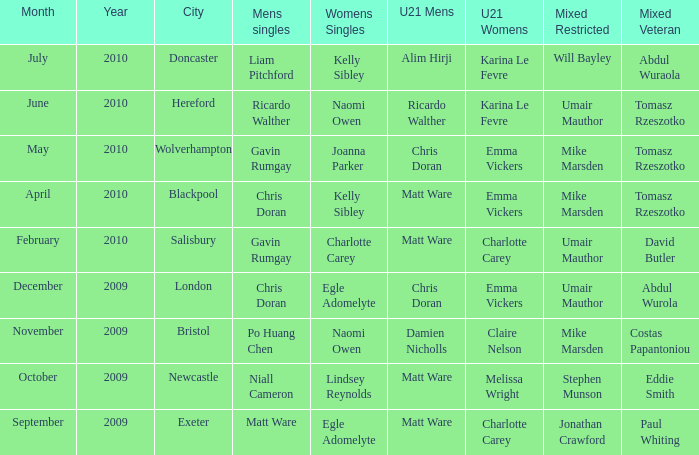When Naomi Owen won the Womens Singles and Ricardo Walther won the Mens Singles, who won the mixed veteran? Tomasz Rzeszotko. 